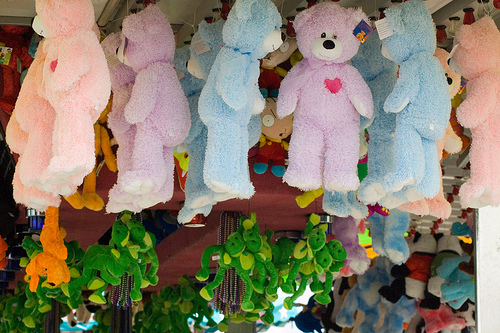<image>
Is the soft toy in the soft toy? No. The soft toy is not contained within the soft toy. These objects have a different spatial relationship. 